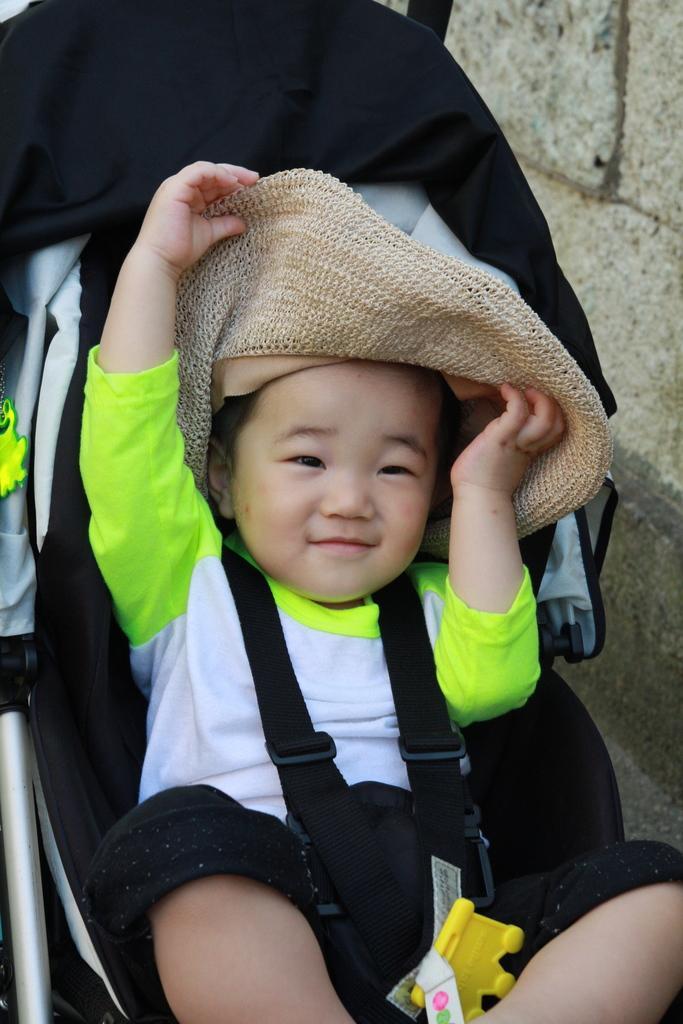How would you summarize this image in a sentence or two? In this picture we can see a baby in a stroller and we can see a wall in the background. 